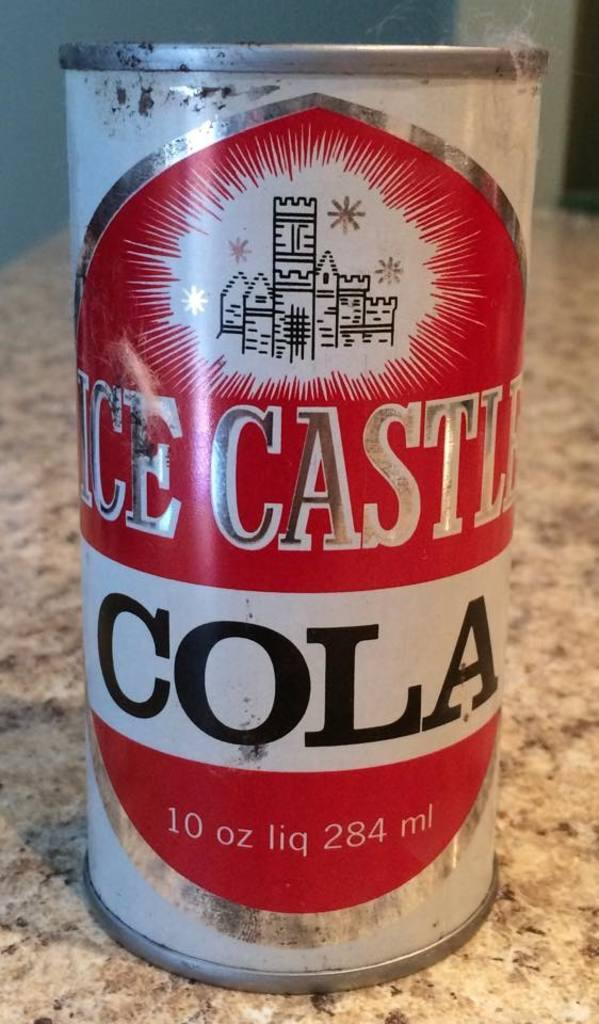<image>
Offer a succinct explanation of the picture presented. A can of ICE CASTLE COLA sits on top of a granite counter 